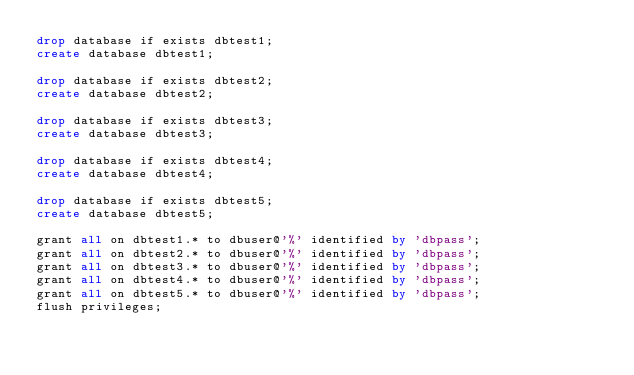<code> <loc_0><loc_0><loc_500><loc_500><_SQL_>drop database if exists dbtest1;
create database dbtest1;

drop database if exists dbtest2;
create database dbtest2;

drop database if exists dbtest3;
create database dbtest3;

drop database if exists dbtest4;
create database dbtest4;

drop database if exists dbtest5;
create database dbtest5;

grant all on dbtest1.* to dbuser@'%' identified by 'dbpass';
grant all on dbtest2.* to dbuser@'%' identified by 'dbpass';
grant all on dbtest3.* to dbuser@'%' identified by 'dbpass';
grant all on dbtest4.* to dbuser@'%' identified by 'dbpass';
grant all on dbtest5.* to dbuser@'%' identified by 'dbpass';
flush privileges;</code> 